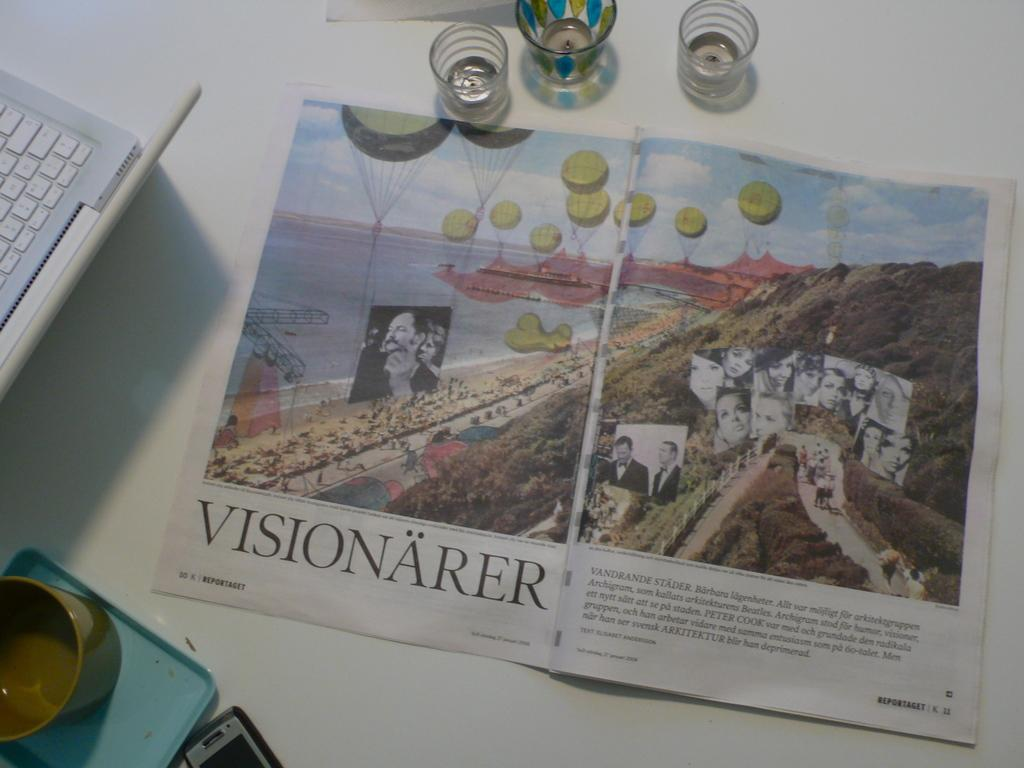<image>
Give a short and clear explanation of the subsequent image. A pamphlet for a company called Visionarer sitting on a table. 